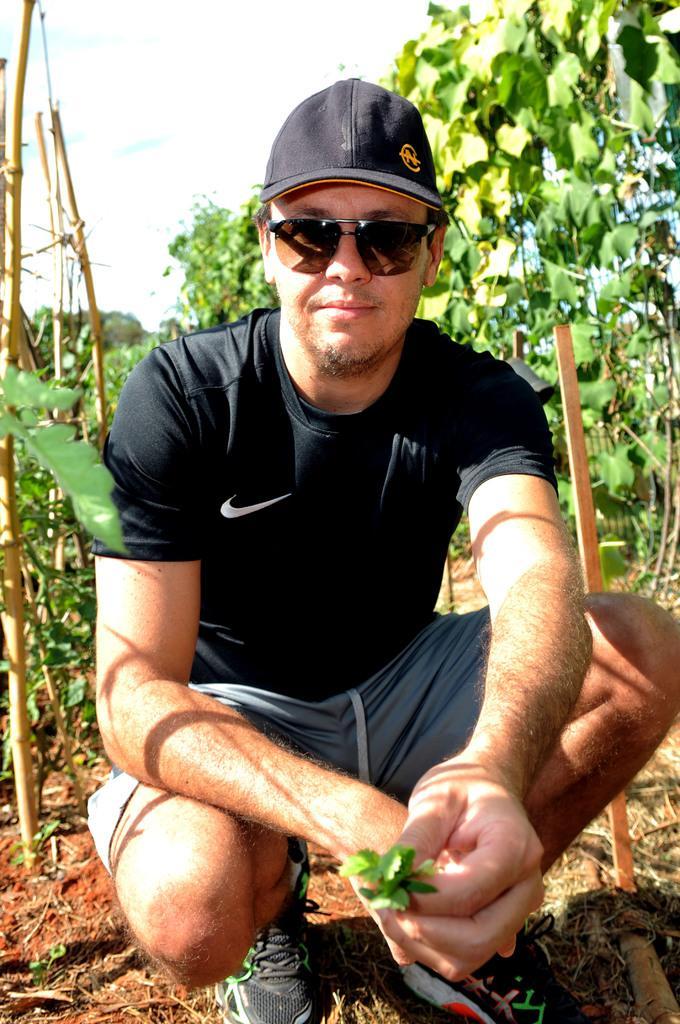Please provide a concise description of this image. In this picture we can see a man wore a cap, goggles, shoes and holding leaves with his hand and smiling and at the back of him we can see plants, sticks and in the background we can see the sky. 